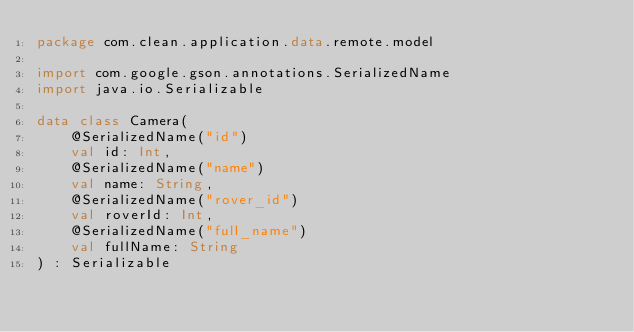Convert code to text. <code><loc_0><loc_0><loc_500><loc_500><_Kotlin_>package com.clean.application.data.remote.model

import com.google.gson.annotations.SerializedName
import java.io.Serializable

data class Camera(
    @SerializedName("id")
    val id: Int,
    @SerializedName("name")
    val name: String,
    @SerializedName("rover_id")
    val roverId: Int,
    @SerializedName("full_name")
    val fullName: String
) : Serializable</code> 